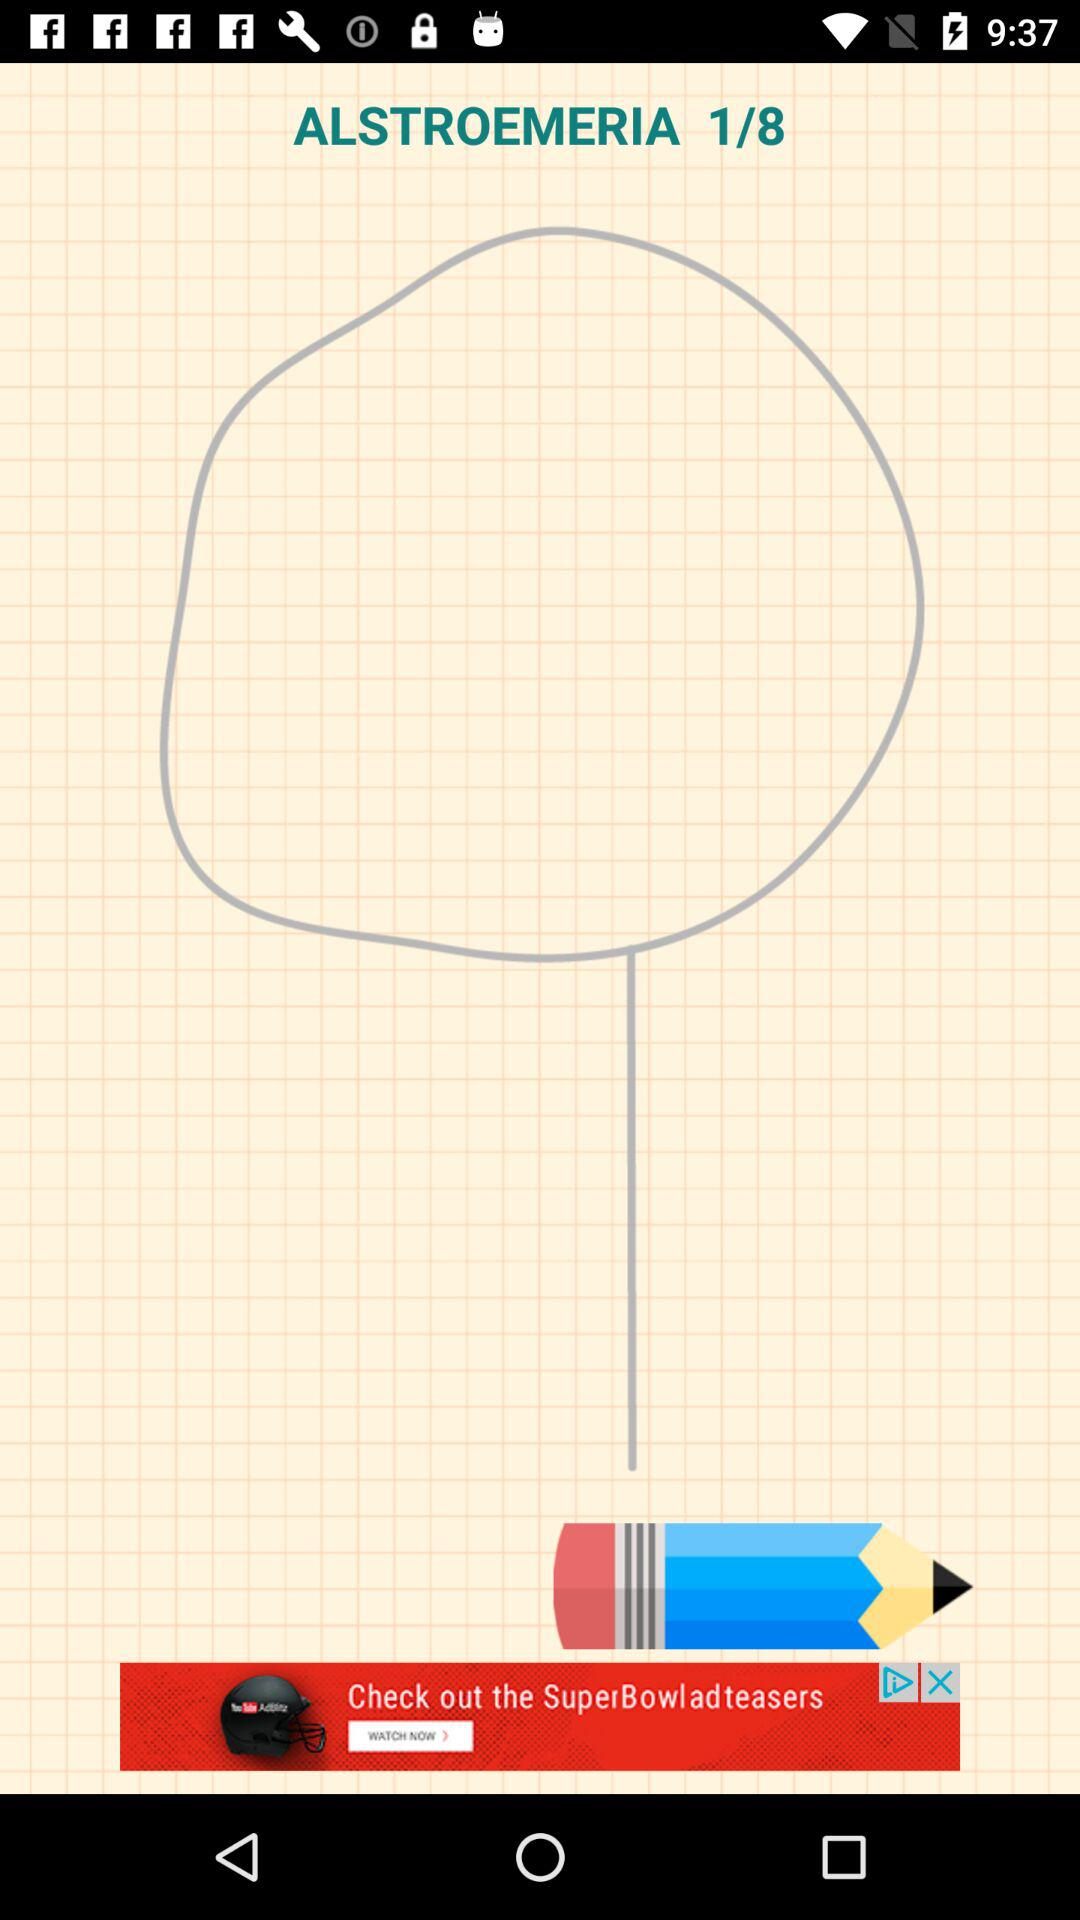What is the name of the application?
When the provided information is insufficient, respond with <no answer>. <no answer> 